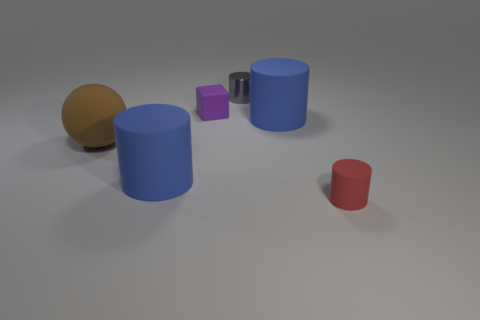Subtract all blue balls. How many blue cylinders are left? 2 Subtract all rubber cylinders. How many cylinders are left? 1 Add 1 metallic cylinders. How many objects exist? 7 Subtract 2 cylinders. How many cylinders are left? 2 Subtract all brown cylinders. Subtract all yellow spheres. How many cylinders are left? 4 Subtract all cylinders. How many objects are left? 2 Subtract all matte spheres. Subtract all large rubber things. How many objects are left? 2 Add 2 purple rubber objects. How many purple rubber objects are left? 3 Add 4 big rubber balls. How many big rubber balls exist? 5 Subtract 1 purple blocks. How many objects are left? 5 